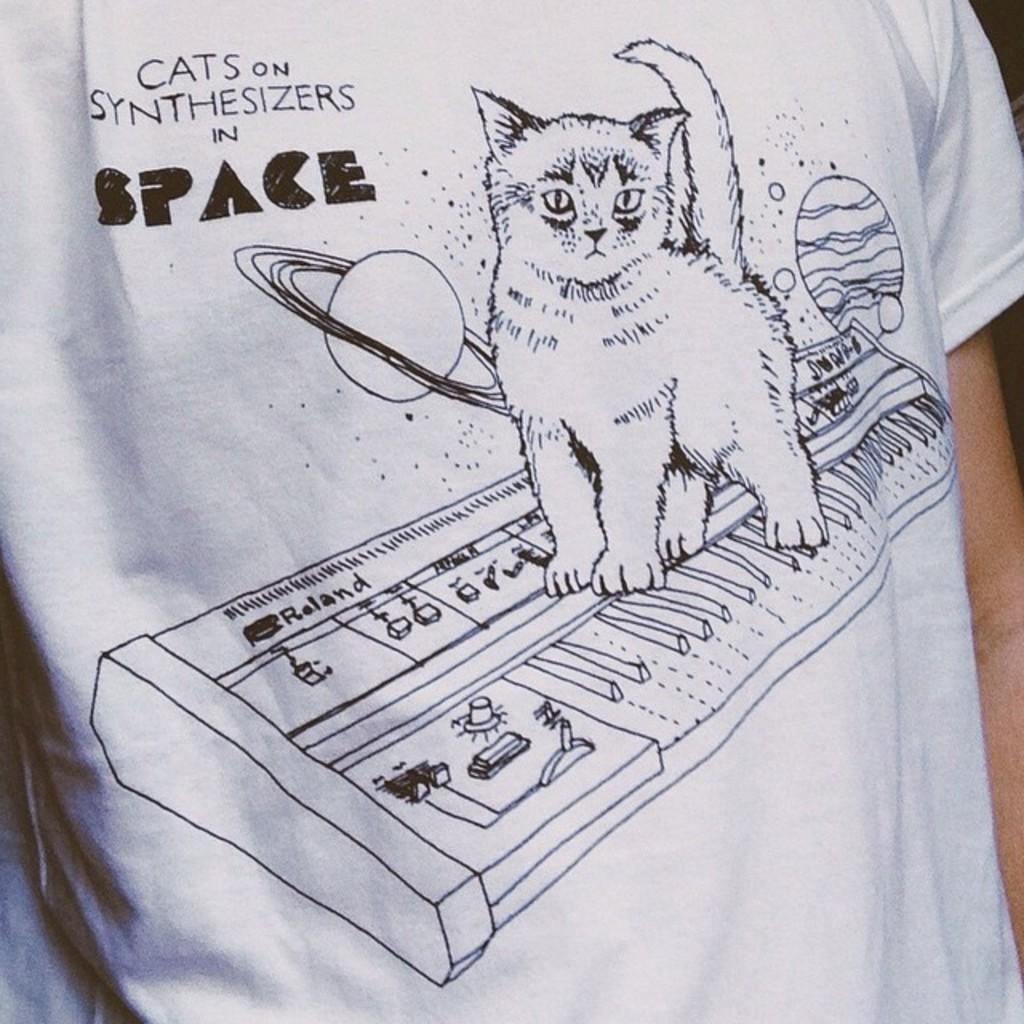What type of clothing item is in the image? There is a T-shirt in the image. What color is the T-shirt? The T-shirt is white. Is there any text on the T-shirt? Yes, there is text on the T-shirt. Where is the text located on the T-shirt? The text is located on the top left side. What images are printed on the T-shirt? There is a cat and a piano printed on the T-shirt. What advice is given on the T-shirt? There is no advice present on the T-shirt; it only has text, a cat, and a piano printed on it. Does the T-shirt have a pocket? The provided facts do not mention a pocket on the T-shirt. 